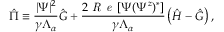Convert formula to latex. <formula><loc_0><loc_0><loc_500><loc_500>\hat { \Pi } \equiv \frac { | \Psi | ^ { 2 } } { \gamma \Lambda _ { \alpha } } \hat { G } + \frac { 2 R e \left [ \Psi ( \Psi ^ { z } ) ^ { * } \right ] } { \gamma \Lambda _ { \alpha } } \left ( \hat { H } - \hat { G } \right ) ,</formula> 